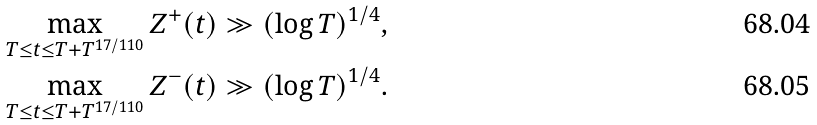Convert formula to latex. <formula><loc_0><loc_0><loc_500><loc_500>& \max _ { T \leq t \leq T + T ^ { 1 7 / 1 1 0 } } Z ^ { + } ( t ) \gg ( \log T ) ^ { 1 / 4 } , \\ & \max _ { T \leq t \leq T + T ^ { 1 7 / 1 1 0 } } Z ^ { - } ( t ) \gg ( \log T ) ^ { 1 / 4 } .</formula> 